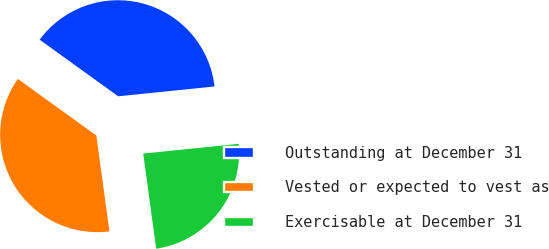Convert chart to OTSL. <chart><loc_0><loc_0><loc_500><loc_500><pie_chart><fcel>Outstanding at December 31<fcel>Vested or expected to vest as<fcel>Exercisable at December 31<nl><fcel>38.44%<fcel>37.1%<fcel>24.46%<nl></chart> 